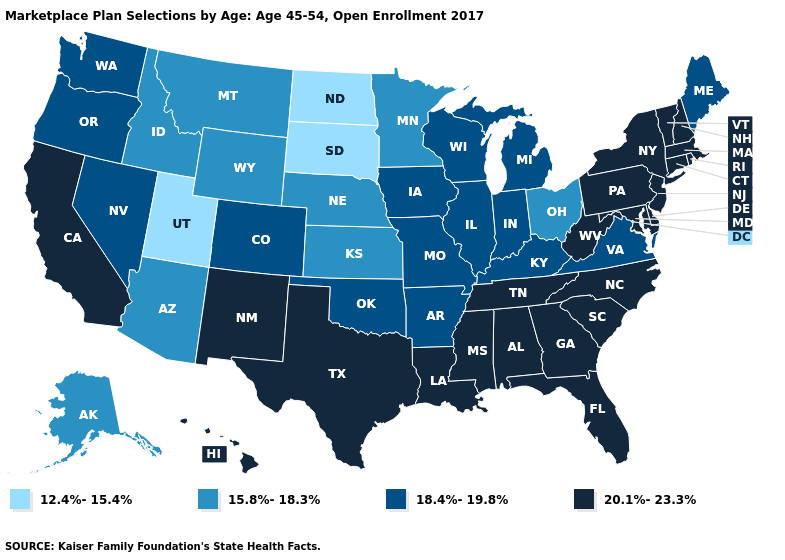Is the legend a continuous bar?
Keep it brief. No. Does Indiana have the same value as Hawaii?
Short answer required. No. Which states have the lowest value in the USA?
Answer briefly. North Dakota, South Dakota, Utah. What is the value of Texas?
Give a very brief answer. 20.1%-23.3%. Among the states that border Texas , does Louisiana have the highest value?
Keep it brief. Yes. Does Vermont have the lowest value in the USA?
Answer briefly. No. Does New Jersey have the highest value in the Northeast?
Give a very brief answer. Yes. What is the value of Delaware?
Concise answer only. 20.1%-23.3%. Among the states that border Michigan , does Ohio have the highest value?
Answer briefly. No. Does Utah have the same value as North Dakota?
Keep it brief. Yes. Name the states that have a value in the range 15.8%-18.3%?
Be succinct. Alaska, Arizona, Idaho, Kansas, Minnesota, Montana, Nebraska, Ohio, Wyoming. Which states hav the highest value in the South?
Short answer required. Alabama, Delaware, Florida, Georgia, Louisiana, Maryland, Mississippi, North Carolina, South Carolina, Tennessee, Texas, West Virginia. Which states have the highest value in the USA?
Concise answer only. Alabama, California, Connecticut, Delaware, Florida, Georgia, Hawaii, Louisiana, Maryland, Massachusetts, Mississippi, New Hampshire, New Jersey, New Mexico, New York, North Carolina, Pennsylvania, Rhode Island, South Carolina, Tennessee, Texas, Vermont, West Virginia. What is the highest value in the South ?
Keep it brief. 20.1%-23.3%. What is the highest value in the USA?
Answer briefly. 20.1%-23.3%. 